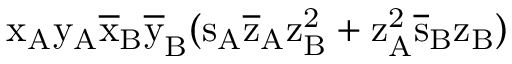Convert formula to latex. <formula><loc_0><loc_0><loc_500><loc_500>x _ { A } \mathrm { y _ { A } \mathrm { \overline { x } _ { B } \mathrm { \overline { y } _ { B } ( \mathrm { s _ { A } \mathrm { \overline { z } _ { A } \mathrm { z _ { B } ^ { 2 } + \mathrm { z _ { A } ^ { 2 } \mathrm { \overline { s } _ { B } \mathrm { z _ { B } ) } } } } } } } } }</formula> 